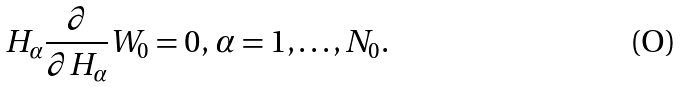Convert formula to latex. <formula><loc_0><loc_0><loc_500><loc_500>H _ { \alpha } \frac { \partial } { \partial H _ { \alpha } } W _ { 0 } = 0 , \, \alpha = 1 , \dots , N _ { 0 } .</formula> 